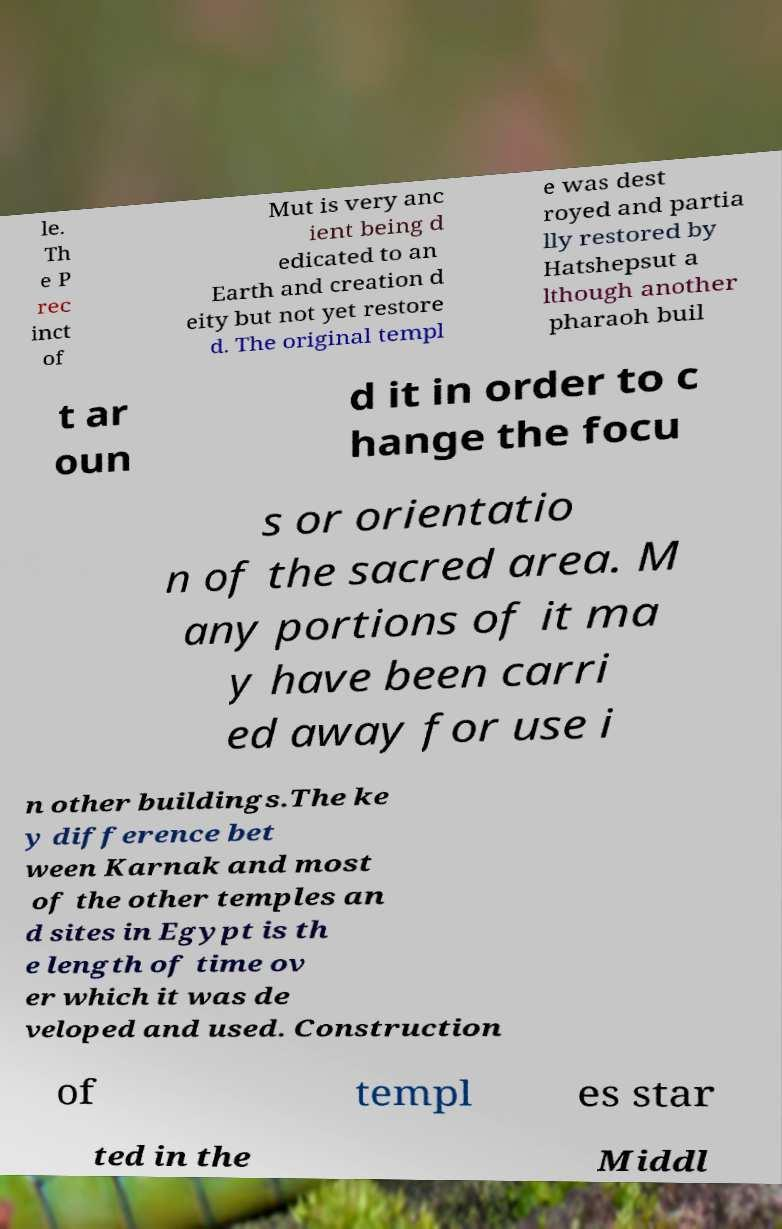Could you extract and type out the text from this image? le. Th e P rec inct of Mut is very anc ient being d edicated to an Earth and creation d eity but not yet restore d. The original templ e was dest royed and partia lly restored by Hatshepsut a lthough another pharaoh buil t ar oun d it in order to c hange the focu s or orientatio n of the sacred area. M any portions of it ma y have been carri ed away for use i n other buildings.The ke y difference bet ween Karnak and most of the other temples an d sites in Egypt is th e length of time ov er which it was de veloped and used. Construction of templ es star ted in the Middl 